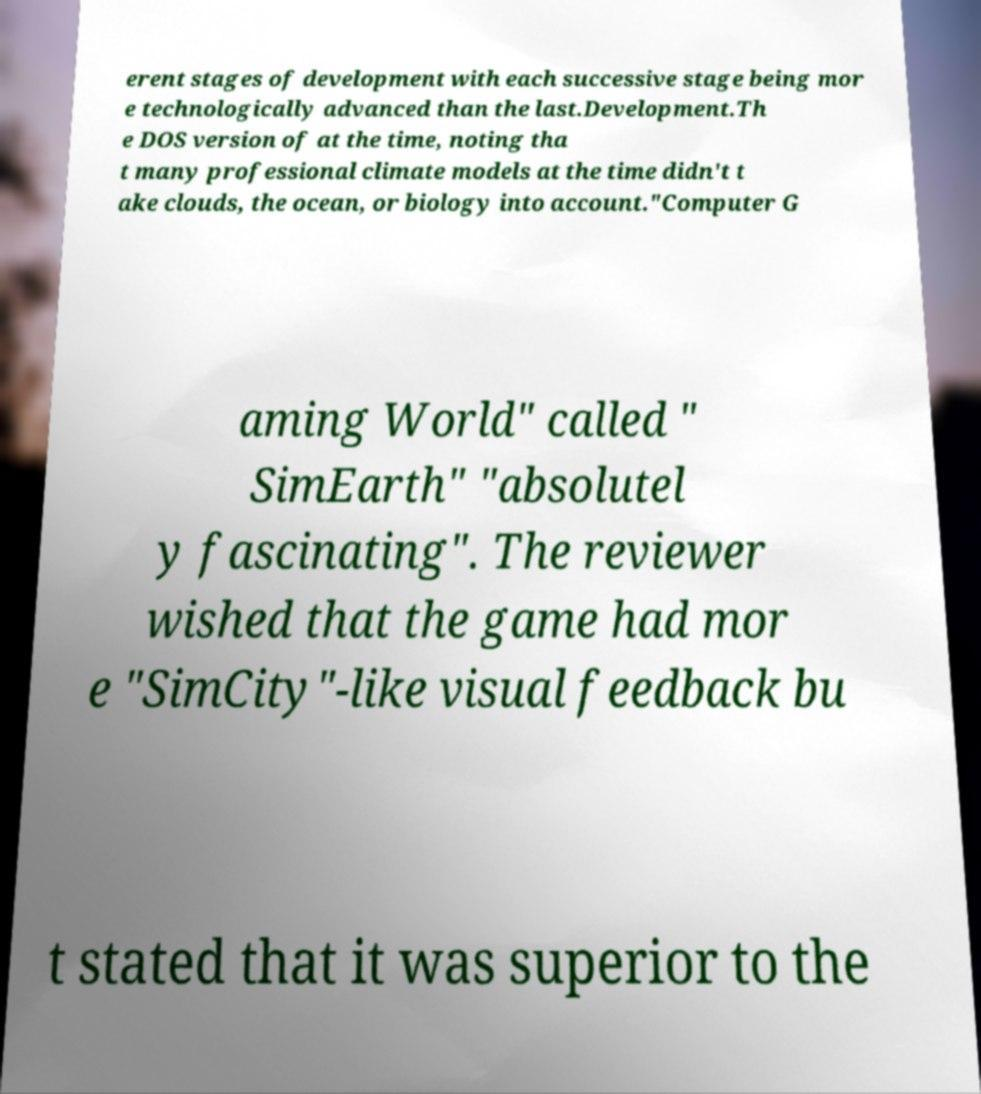Can you read and provide the text displayed in the image?This photo seems to have some interesting text. Can you extract and type it out for me? erent stages of development with each successive stage being mor e technologically advanced than the last.Development.Th e DOS version of at the time, noting tha t many professional climate models at the time didn't t ake clouds, the ocean, or biology into account."Computer G aming World" called " SimEarth" "absolutel y fascinating". The reviewer wished that the game had mor e "SimCity"-like visual feedback bu t stated that it was superior to the 